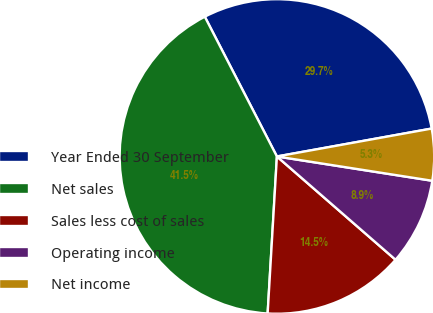<chart> <loc_0><loc_0><loc_500><loc_500><pie_chart><fcel>Year Ended 30 September<fcel>Net sales<fcel>Sales less cost of sales<fcel>Operating income<fcel>Net income<nl><fcel>29.74%<fcel>41.48%<fcel>14.54%<fcel>8.93%<fcel>5.31%<nl></chart> 